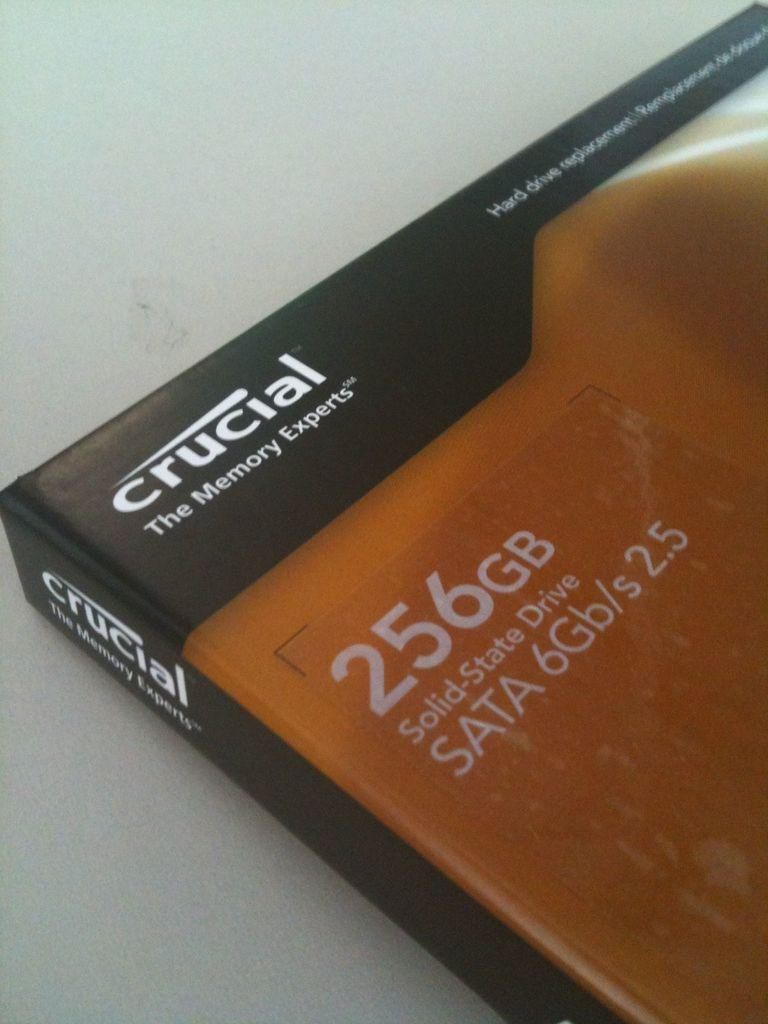<image>
Present a compact description of the photo's key features. The book has the information written on the front 256GB solid state drive. 